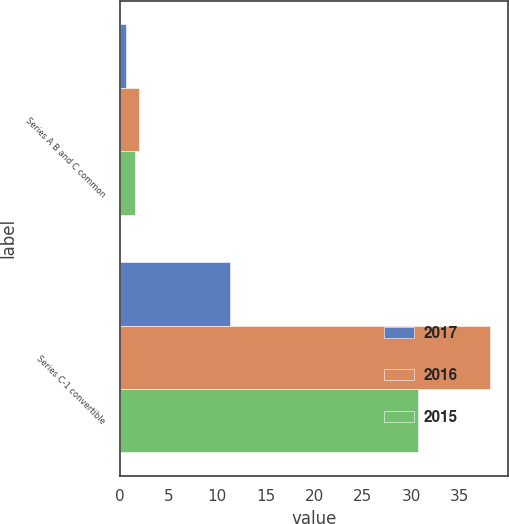Convert chart to OTSL. <chart><loc_0><loc_0><loc_500><loc_500><stacked_bar_chart><ecel><fcel>Series A B and C common<fcel>Series C-1 convertible<nl><fcel>2017<fcel>0.59<fcel>11.33<nl><fcel>2016<fcel>1.97<fcel>38.07<nl><fcel>2015<fcel>1.59<fcel>30.74<nl></chart> 